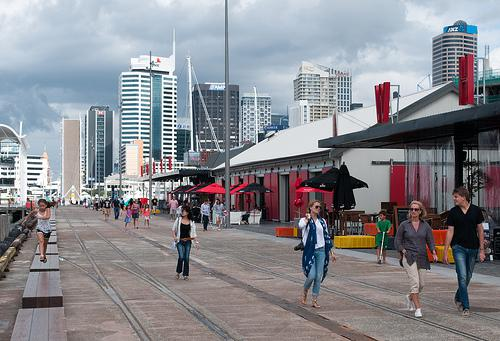Question: what type of clouds are those?
Choices:
A. White.
B. Storm.
C. Grey.
D. Puffy.
Answer with the letter. Answer: B Question: how is the weather?
Choices:
A. Sunny.
B. Overcast.
C. Snowy.
D. Hazy.
Answer with the letter. Answer: B Question: what are the people in the picture doing?
Choices:
A. Walking.
B. Laughing.
C. Eating.
D. Sleeping.
Answer with the letter. Answer: A Question: what is in the sky?
Choices:
A. Clouds.
B. A bird.
C. A kite.
D. A plane.
Answer with the letter. Answer: A Question: where are the buildings?
Choices:
A. Next to the park.
B. In the back.
C. Next to the lake.
D. In front of the bridge.
Answer with the letter. Answer: B 